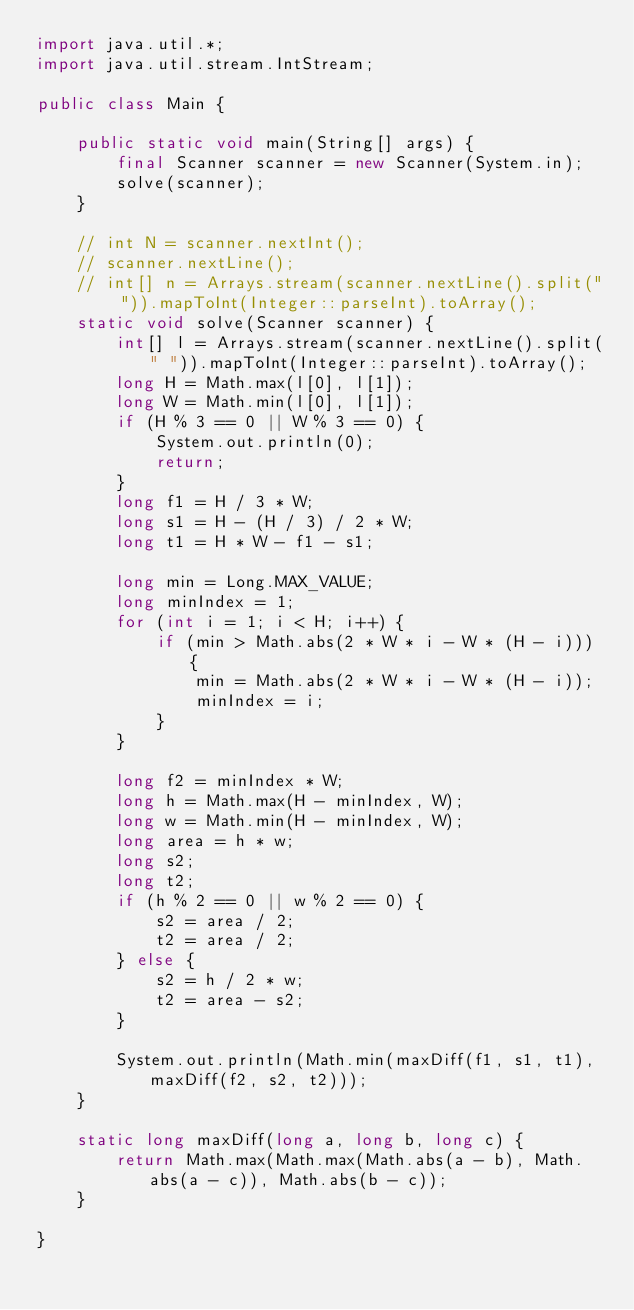<code> <loc_0><loc_0><loc_500><loc_500><_Java_>import java.util.*;
import java.util.stream.IntStream;

public class Main {

    public static void main(String[] args) {
        final Scanner scanner = new Scanner(System.in);
        solve(scanner);
    }

    // int N = scanner.nextInt();
    // scanner.nextLine();
    // int[] n = Arrays.stream(scanner.nextLine().split(" ")).mapToInt(Integer::parseInt).toArray();
    static void solve(Scanner scanner) {
        int[] l = Arrays.stream(scanner.nextLine().split(" ")).mapToInt(Integer::parseInt).toArray();
        long H = Math.max(l[0], l[1]);
        long W = Math.min(l[0], l[1]);
        if (H % 3 == 0 || W % 3 == 0) {
            System.out.println(0);
            return;
        }
        long f1 = H / 3 * W;
        long s1 = H - (H / 3) / 2 * W;
        long t1 = H * W - f1 - s1;

        long min = Long.MAX_VALUE;
        long minIndex = 1;
        for (int i = 1; i < H; i++) {
            if (min > Math.abs(2 * W * i - W * (H - i))) {
                min = Math.abs(2 * W * i - W * (H - i));
                minIndex = i;
            }
        }

        long f2 = minIndex * W;
        long h = Math.max(H - minIndex, W);
        long w = Math.min(H - minIndex, W);
        long area = h * w;
        long s2;
        long t2;
        if (h % 2 == 0 || w % 2 == 0) {
            s2 = area / 2;
            t2 = area / 2;
        } else {
            s2 = h / 2 * w;
            t2 = area - s2;
        }

        System.out.println(Math.min(maxDiff(f1, s1, t1), maxDiff(f2, s2, t2)));
    }

    static long maxDiff(long a, long b, long c) {
        return Math.max(Math.max(Math.abs(a - b), Math.abs(a - c)), Math.abs(b - c));
    }

}
</code> 